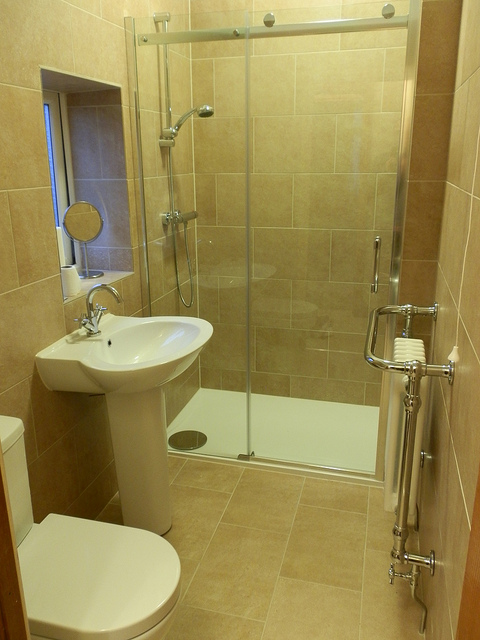<image>What type of bathtub is that? There is no bathtub in the image. It appears to be a shower stall. What type of bathtub is that? There is no bathtub in the image. 